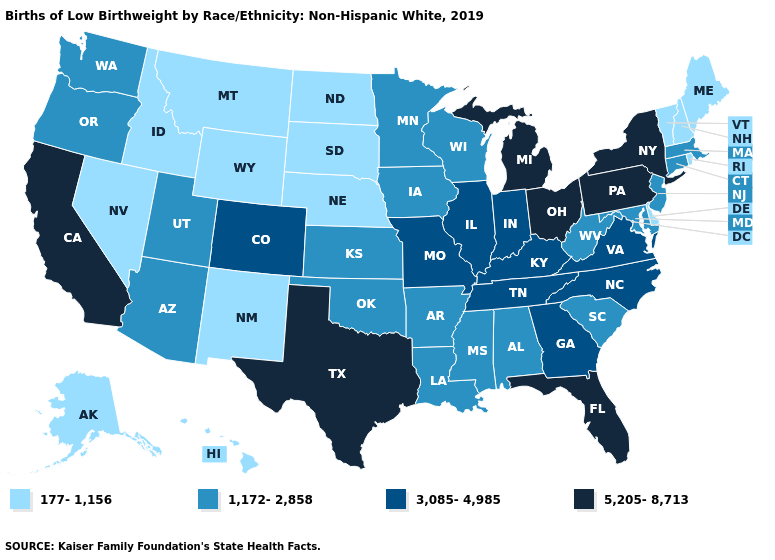Which states hav the highest value in the South?
Short answer required. Florida, Texas. Among the states that border Wisconsin , does Minnesota have the lowest value?
Short answer required. Yes. Does the first symbol in the legend represent the smallest category?
Answer briefly. Yes. Among the states that border Idaho , which have the lowest value?
Keep it brief. Montana, Nevada, Wyoming. Does the first symbol in the legend represent the smallest category?
Concise answer only. Yes. What is the value of Maine?
Write a very short answer. 177-1,156. Which states have the highest value in the USA?
Keep it brief. California, Florida, Michigan, New York, Ohio, Pennsylvania, Texas. Among the states that border Illinois , does Wisconsin have the highest value?
Write a very short answer. No. What is the value of Tennessee?
Answer briefly. 3,085-4,985. Does the map have missing data?
Write a very short answer. No. Name the states that have a value in the range 177-1,156?
Short answer required. Alaska, Delaware, Hawaii, Idaho, Maine, Montana, Nebraska, Nevada, New Hampshire, New Mexico, North Dakota, Rhode Island, South Dakota, Vermont, Wyoming. Does the map have missing data?
Answer briefly. No. Name the states that have a value in the range 5,205-8,713?
Answer briefly. California, Florida, Michigan, New York, Ohio, Pennsylvania, Texas. Name the states that have a value in the range 3,085-4,985?
Quick response, please. Colorado, Georgia, Illinois, Indiana, Kentucky, Missouri, North Carolina, Tennessee, Virginia. 